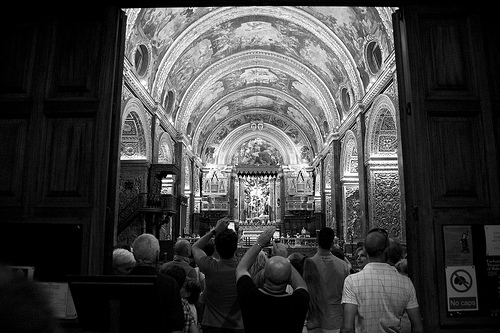Imagine a story involving a hidden treasure within this church. What's the story? Once upon a time, this church was known to harbor a hidden treasure left by a benevolent king. Legend has it that within the miles of intricate carvings and secret passages, a map revealing the location of a chest filled with gold and precious artifacts was concealed. Brave explorers often visit, hoping to uncover clues and finally bring the treasure to light. The grand altar with its striking design was said to possess hidden compartments that would only reveal the next clue when a specific hymn was sung. 